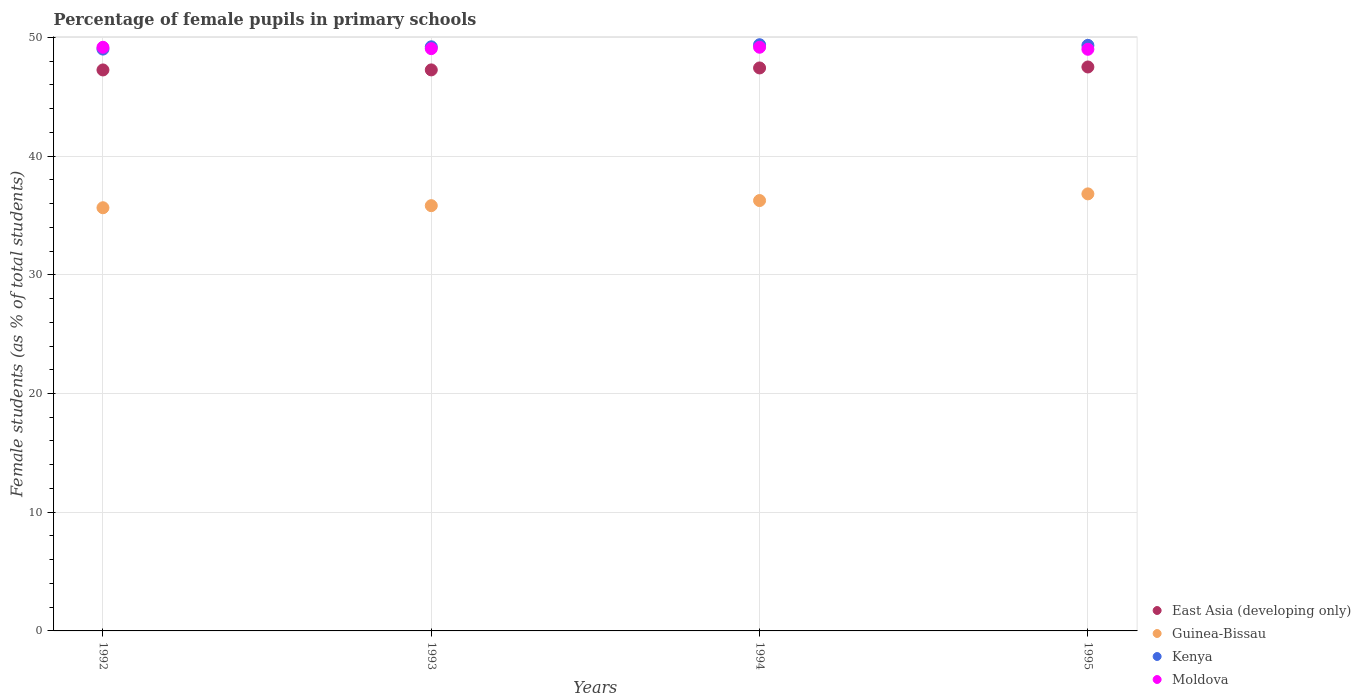What is the percentage of female pupils in primary schools in Kenya in 1994?
Your response must be concise. 49.38. Across all years, what is the maximum percentage of female pupils in primary schools in Kenya?
Give a very brief answer. 49.38. Across all years, what is the minimum percentage of female pupils in primary schools in Moldova?
Your answer should be compact. 49. In which year was the percentage of female pupils in primary schools in Kenya minimum?
Ensure brevity in your answer.  1992. What is the total percentage of female pupils in primary schools in Kenya in the graph?
Ensure brevity in your answer.  196.94. What is the difference between the percentage of female pupils in primary schools in Guinea-Bissau in 1992 and that in 1994?
Provide a succinct answer. -0.61. What is the difference between the percentage of female pupils in primary schools in East Asia (developing only) in 1992 and the percentage of female pupils in primary schools in Kenya in 1995?
Make the answer very short. -2.07. What is the average percentage of female pupils in primary schools in Moldova per year?
Provide a succinct answer. 49.1. In the year 1994, what is the difference between the percentage of female pupils in primary schools in Kenya and percentage of female pupils in primary schools in Moldova?
Give a very brief answer. 0.21. What is the ratio of the percentage of female pupils in primary schools in Kenya in 1992 to that in 1993?
Your answer should be very brief. 1. Is the difference between the percentage of female pupils in primary schools in Kenya in 1992 and 1995 greater than the difference between the percentage of female pupils in primary schools in Moldova in 1992 and 1995?
Your response must be concise. No. What is the difference between the highest and the second highest percentage of female pupils in primary schools in East Asia (developing only)?
Your answer should be compact. 0.08. What is the difference between the highest and the lowest percentage of female pupils in primary schools in East Asia (developing only)?
Your response must be concise. 0.25. Is the sum of the percentage of female pupils in primary schools in Guinea-Bissau in 1993 and 1995 greater than the maximum percentage of female pupils in primary schools in Kenya across all years?
Give a very brief answer. Yes. Does the percentage of female pupils in primary schools in Guinea-Bissau monotonically increase over the years?
Your response must be concise. Yes. Is the percentage of female pupils in primary schools in East Asia (developing only) strictly less than the percentage of female pupils in primary schools in Guinea-Bissau over the years?
Provide a succinct answer. No. How many years are there in the graph?
Give a very brief answer. 4. What is the difference between two consecutive major ticks on the Y-axis?
Make the answer very short. 10. Does the graph contain grids?
Keep it short and to the point. Yes. What is the title of the graph?
Your answer should be compact. Percentage of female pupils in primary schools. Does "Syrian Arab Republic" appear as one of the legend labels in the graph?
Keep it short and to the point. No. What is the label or title of the X-axis?
Your answer should be very brief. Years. What is the label or title of the Y-axis?
Give a very brief answer. Female students (as % of total students). What is the Female students (as % of total students) of East Asia (developing only) in 1992?
Your answer should be compact. 47.26. What is the Female students (as % of total students) in Guinea-Bissau in 1992?
Keep it short and to the point. 35.65. What is the Female students (as % of total students) of Kenya in 1992?
Provide a succinct answer. 49.02. What is the Female students (as % of total students) of Moldova in 1992?
Ensure brevity in your answer.  49.17. What is the Female students (as % of total students) of East Asia (developing only) in 1993?
Provide a short and direct response. 47.26. What is the Female students (as % of total students) of Guinea-Bissau in 1993?
Provide a short and direct response. 35.83. What is the Female students (as % of total students) in Kenya in 1993?
Provide a succinct answer. 49.21. What is the Female students (as % of total students) of Moldova in 1993?
Offer a very short reply. 49.05. What is the Female students (as % of total students) in East Asia (developing only) in 1994?
Your answer should be compact. 47.43. What is the Female students (as % of total students) in Guinea-Bissau in 1994?
Provide a short and direct response. 36.26. What is the Female students (as % of total students) of Kenya in 1994?
Your response must be concise. 49.38. What is the Female students (as % of total students) in Moldova in 1994?
Provide a succinct answer. 49.17. What is the Female students (as % of total students) of East Asia (developing only) in 1995?
Provide a short and direct response. 47.51. What is the Female students (as % of total students) in Guinea-Bissau in 1995?
Offer a very short reply. 36.82. What is the Female students (as % of total students) of Kenya in 1995?
Keep it short and to the point. 49.33. What is the Female students (as % of total students) in Moldova in 1995?
Give a very brief answer. 49. Across all years, what is the maximum Female students (as % of total students) in East Asia (developing only)?
Provide a short and direct response. 47.51. Across all years, what is the maximum Female students (as % of total students) in Guinea-Bissau?
Your answer should be very brief. 36.82. Across all years, what is the maximum Female students (as % of total students) of Kenya?
Your answer should be compact. 49.38. Across all years, what is the maximum Female students (as % of total students) in Moldova?
Provide a short and direct response. 49.17. Across all years, what is the minimum Female students (as % of total students) in East Asia (developing only)?
Your answer should be very brief. 47.26. Across all years, what is the minimum Female students (as % of total students) in Guinea-Bissau?
Offer a very short reply. 35.65. Across all years, what is the minimum Female students (as % of total students) of Kenya?
Your answer should be compact. 49.02. Across all years, what is the minimum Female students (as % of total students) of Moldova?
Offer a very short reply. 49. What is the total Female students (as % of total students) of East Asia (developing only) in the graph?
Give a very brief answer. 189.46. What is the total Female students (as % of total students) in Guinea-Bissau in the graph?
Your answer should be very brief. 144.55. What is the total Female students (as % of total students) of Kenya in the graph?
Ensure brevity in your answer.  196.94. What is the total Female students (as % of total students) in Moldova in the graph?
Give a very brief answer. 196.39. What is the difference between the Female students (as % of total students) in East Asia (developing only) in 1992 and that in 1993?
Provide a succinct answer. -0. What is the difference between the Female students (as % of total students) of Guinea-Bissau in 1992 and that in 1993?
Provide a short and direct response. -0.18. What is the difference between the Female students (as % of total students) of Kenya in 1992 and that in 1993?
Make the answer very short. -0.19. What is the difference between the Female students (as % of total students) of Moldova in 1992 and that in 1993?
Ensure brevity in your answer.  0.11. What is the difference between the Female students (as % of total students) of East Asia (developing only) in 1992 and that in 1994?
Offer a very short reply. -0.17. What is the difference between the Female students (as % of total students) of Guinea-Bissau in 1992 and that in 1994?
Make the answer very short. -0.61. What is the difference between the Female students (as % of total students) of Kenya in 1992 and that in 1994?
Your response must be concise. -0.37. What is the difference between the Female students (as % of total students) in Moldova in 1992 and that in 1994?
Offer a terse response. -0. What is the difference between the Female students (as % of total students) in East Asia (developing only) in 1992 and that in 1995?
Your answer should be compact. -0.25. What is the difference between the Female students (as % of total students) in Guinea-Bissau in 1992 and that in 1995?
Your response must be concise. -1.17. What is the difference between the Female students (as % of total students) of Kenya in 1992 and that in 1995?
Provide a short and direct response. -0.31. What is the difference between the Female students (as % of total students) of Moldova in 1992 and that in 1995?
Offer a terse response. 0.17. What is the difference between the Female students (as % of total students) in East Asia (developing only) in 1993 and that in 1994?
Your answer should be very brief. -0.16. What is the difference between the Female students (as % of total students) of Guinea-Bissau in 1993 and that in 1994?
Your answer should be compact. -0.43. What is the difference between the Female students (as % of total students) in Kenya in 1993 and that in 1994?
Make the answer very short. -0.17. What is the difference between the Female students (as % of total students) in Moldova in 1993 and that in 1994?
Offer a very short reply. -0.12. What is the difference between the Female students (as % of total students) of East Asia (developing only) in 1993 and that in 1995?
Ensure brevity in your answer.  -0.25. What is the difference between the Female students (as % of total students) in Guinea-Bissau in 1993 and that in 1995?
Your answer should be compact. -0.99. What is the difference between the Female students (as % of total students) of Kenya in 1993 and that in 1995?
Your answer should be very brief. -0.12. What is the difference between the Female students (as % of total students) of Moldova in 1993 and that in 1995?
Keep it short and to the point. 0.05. What is the difference between the Female students (as % of total students) of East Asia (developing only) in 1994 and that in 1995?
Ensure brevity in your answer.  -0.08. What is the difference between the Female students (as % of total students) in Guinea-Bissau in 1994 and that in 1995?
Offer a very short reply. -0.56. What is the difference between the Female students (as % of total students) of Kenya in 1994 and that in 1995?
Provide a succinct answer. 0.05. What is the difference between the Female students (as % of total students) of Moldova in 1994 and that in 1995?
Your answer should be compact. 0.17. What is the difference between the Female students (as % of total students) of East Asia (developing only) in 1992 and the Female students (as % of total students) of Guinea-Bissau in 1993?
Your answer should be compact. 11.43. What is the difference between the Female students (as % of total students) of East Asia (developing only) in 1992 and the Female students (as % of total students) of Kenya in 1993?
Provide a short and direct response. -1.95. What is the difference between the Female students (as % of total students) of East Asia (developing only) in 1992 and the Female students (as % of total students) of Moldova in 1993?
Your answer should be compact. -1.79. What is the difference between the Female students (as % of total students) of Guinea-Bissau in 1992 and the Female students (as % of total students) of Kenya in 1993?
Ensure brevity in your answer.  -13.56. What is the difference between the Female students (as % of total students) in Guinea-Bissau in 1992 and the Female students (as % of total students) in Moldova in 1993?
Make the answer very short. -13.4. What is the difference between the Female students (as % of total students) of Kenya in 1992 and the Female students (as % of total students) of Moldova in 1993?
Offer a very short reply. -0.04. What is the difference between the Female students (as % of total students) of East Asia (developing only) in 1992 and the Female students (as % of total students) of Guinea-Bissau in 1994?
Offer a terse response. 11. What is the difference between the Female students (as % of total students) in East Asia (developing only) in 1992 and the Female students (as % of total students) in Kenya in 1994?
Your answer should be very brief. -2.12. What is the difference between the Female students (as % of total students) of East Asia (developing only) in 1992 and the Female students (as % of total students) of Moldova in 1994?
Provide a succinct answer. -1.91. What is the difference between the Female students (as % of total students) in Guinea-Bissau in 1992 and the Female students (as % of total students) in Kenya in 1994?
Provide a short and direct response. -13.73. What is the difference between the Female students (as % of total students) of Guinea-Bissau in 1992 and the Female students (as % of total students) of Moldova in 1994?
Your response must be concise. -13.52. What is the difference between the Female students (as % of total students) of Kenya in 1992 and the Female students (as % of total students) of Moldova in 1994?
Provide a short and direct response. -0.16. What is the difference between the Female students (as % of total students) in East Asia (developing only) in 1992 and the Female students (as % of total students) in Guinea-Bissau in 1995?
Make the answer very short. 10.44. What is the difference between the Female students (as % of total students) in East Asia (developing only) in 1992 and the Female students (as % of total students) in Kenya in 1995?
Provide a short and direct response. -2.07. What is the difference between the Female students (as % of total students) of East Asia (developing only) in 1992 and the Female students (as % of total students) of Moldova in 1995?
Provide a succinct answer. -1.74. What is the difference between the Female students (as % of total students) of Guinea-Bissau in 1992 and the Female students (as % of total students) of Kenya in 1995?
Give a very brief answer. -13.68. What is the difference between the Female students (as % of total students) in Guinea-Bissau in 1992 and the Female students (as % of total students) in Moldova in 1995?
Your answer should be very brief. -13.35. What is the difference between the Female students (as % of total students) of Kenya in 1992 and the Female students (as % of total students) of Moldova in 1995?
Your answer should be very brief. 0.02. What is the difference between the Female students (as % of total students) of East Asia (developing only) in 1993 and the Female students (as % of total students) of Guinea-Bissau in 1994?
Your answer should be compact. 11.01. What is the difference between the Female students (as % of total students) of East Asia (developing only) in 1993 and the Female students (as % of total students) of Kenya in 1994?
Your answer should be very brief. -2.12. What is the difference between the Female students (as % of total students) in East Asia (developing only) in 1993 and the Female students (as % of total students) in Moldova in 1994?
Give a very brief answer. -1.91. What is the difference between the Female students (as % of total students) in Guinea-Bissau in 1993 and the Female students (as % of total students) in Kenya in 1994?
Your answer should be very brief. -13.56. What is the difference between the Female students (as % of total students) in Guinea-Bissau in 1993 and the Female students (as % of total students) in Moldova in 1994?
Offer a terse response. -13.35. What is the difference between the Female students (as % of total students) of Kenya in 1993 and the Female students (as % of total students) of Moldova in 1994?
Your response must be concise. 0.04. What is the difference between the Female students (as % of total students) of East Asia (developing only) in 1993 and the Female students (as % of total students) of Guinea-Bissau in 1995?
Offer a very short reply. 10.44. What is the difference between the Female students (as % of total students) in East Asia (developing only) in 1993 and the Female students (as % of total students) in Kenya in 1995?
Keep it short and to the point. -2.07. What is the difference between the Female students (as % of total students) of East Asia (developing only) in 1993 and the Female students (as % of total students) of Moldova in 1995?
Keep it short and to the point. -1.74. What is the difference between the Female students (as % of total students) in Guinea-Bissau in 1993 and the Female students (as % of total students) in Kenya in 1995?
Keep it short and to the point. -13.5. What is the difference between the Female students (as % of total students) of Guinea-Bissau in 1993 and the Female students (as % of total students) of Moldova in 1995?
Make the answer very short. -13.17. What is the difference between the Female students (as % of total students) in Kenya in 1993 and the Female students (as % of total students) in Moldova in 1995?
Ensure brevity in your answer.  0.21. What is the difference between the Female students (as % of total students) in East Asia (developing only) in 1994 and the Female students (as % of total students) in Guinea-Bissau in 1995?
Your response must be concise. 10.61. What is the difference between the Female students (as % of total students) of East Asia (developing only) in 1994 and the Female students (as % of total students) of Kenya in 1995?
Offer a very short reply. -1.9. What is the difference between the Female students (as % of total students) in East Asia (developing only) in 1994 and the Female students (as % of total students) in Moldova in 1995?
Your answer should be compact. -1.57. What is the difference between the Female students (as % of total students) in Guinea-Bissau in 1994 and the Female students (as % of total students) in Kenya in 1995?
Keep it short and to the point. -13.07. What is the difference between the Female students (as % of total students) of Guinea-Bissau in 1994 and the Female students (as % of total students) of Moldova in 1995?
Your response must be concise. -12.74. What is the difference between the Female students (as % of total students) in Kenya in 1994 and the Female students (as % of total students) in Moldova in 1995?
Your answer should be very brief. 0.38. What is the average Female students (as % of total students) in East Asia (developing only) per year?
Provide a succinct answer. 47.36. What is the average Female students (as % of total students) in Guinea-Bissau per year?
Ensure brevity in your answer.  36.14. What is the average Female students (as % of total students) in Kenya per year?
Provide a short and direct response. 49.23. What is the average Female students (as % of total students) in Moldova per year?
Your response must be concise. 49.1. In the year 1992, what is the difference between the Female students (as % of total students) in East Asia (developing only) and Female students (as % of total students) in Guinea-Bissau?
Offer a terse response. 11.61. In the year 1992, what is the difference between the Female students (as % of total students) of East Asia (developing only) and Female students (as % of total students) of Kenya?
Keep it short and to the point. -1.76. In the year 1992, what is the difference between the Female students (as % of total students) in East Asia (developing only) and Female students (as % of total students) in Moldova?
Provide a succinct answer. -1.91. In the year 1992, what is the difference between the Female students (as % of total students) of Guinea-Bissau and Female students (as % of total students) of Kenya?
Offer a very short reply. -13.37. In the year 1992, what is the difference between the Female students (as % of total students) in Guinea-Bissau and Female students (as % of total students) in Moldova?
Ensure brevity in your answer.  -13.52. In the year 1992, what is the difference between the Female students (as % of total students) of Kenya and Female students (as % of total students) of Moldova?
Your response must be concise. -0.15. In the year 1993, what is the difference between the Female students (as % of total students) of East Asia (developing only) and Female students (as % of total students) of Guinea-Bissau?
Provide a short and direct response. 11.44. In the year 1993, what is the difference between the Female students (as % of total students) in East Asia (developing only) and Female students (as % of total students) in Kenya?
Provide a short and direct response. -1.95. In the year 1993, what is the difference between the Female students (as % of total students) of East Asia (developing only) and Female students (as % of total students) of Moldova?
Provide a short and direct response. -1.79. In the year 1993, what is the difference between the Female students (as % of total students) in Guinea-Bissau and Female students (as % of total students) in Kenya?
Provide a short and direct response. -13.38. In the year 1993, what is the difference between the Female students (as % of total students) of Guinea-Bissau and Female students (as % of total students) of Moldova?
Provide a succinct answer. -13.23. In the year 1993, what is the difference between the Female students (as % of total students) of Kenya and Female students (as % of total students) of Moldova?
Your answer should be very brief. 0.16. In the year 1994, what is the difference between the Female students (as % of total students) of East Asia (developing only) and Female students (as % of total students) of Guinea-Bissau?
Provide a short and direct response. 11.17. In the year 1994, what is the difference between the Female students (as % of total students) of East Asia (developing only) and Female students (as % of total students) of Kenya?
Your answer should be very brief. -1.96. In the year 1994, what is the difference between the Female students (as % of total students) of East Asia (developing only) and Female students (as % of total students) of Moldova?
Keep it short and to the point. -1.74. In the year 1994, what is the difference between the Female students (as % of total students) in Guinea-Bissau and Female students (as % of total students) in Kenya?
Offer a very short reply. -13.13. In the year 1994, what is the difference between the Female students (as % of total students) of Guinea-Bissau and Female students (as % of total students) of Moldova?
Your answer should be compact. -12.92. In the year 1994, what is the difference between the Female students (as % of total students) of Kenya and Female students (as % of total students) of Moldova?
Your answer should be compact. 0.21. In the year 1995, what is the difference between the Female students (as % of total students) in East Asia (developing only) and Female students (as % of total students) in Guinea-Bissau?
Offer a very short reply. 10.69. In the year 1995, what is the difference between the Female students (as % of total students) of East Asia (developing only) and Female students (as % of total students) of Kenya?
Give a very brief answer. -1.82. In the year 1995, what is the difference between the Female students (as % of total students) in East Asia (developing only) and Female students (as % of total students) in Moldova?
Make the answer very short. -1.49. In the year 1995, what is the difference between the Female students (as % of total students) in Guinea-Bissau and Female students (as % of total students) in Kenya?
Your response must be concise. -12.51. In the year 1995, what is the difference between the Female students (as % of total students) of Guinea-Bissau and Female students (as % of total students) of Moldova?
Offer a terse response. -12.18. In the year 1995, what is the difference between the Female students (as % of total students) of Kenya and Female students (as % of total students) of Moldova?
Keep it short and to the point. 0.33. What is the ratio of the Female students (as % of total students) in East Asia (developing only) in 1992 to that in 1993?
Offer a terse response. 1. What is the ratio of the Female students (as % of total students) of Guinea-Bissau in 1992 to that in 1994?
Provide a succinct answer. 0.98. What is the ratio of the Female students (as % of total students) in Moldova in 1992 to that in 1994?
Your answer should be very brief. 1. What is the ratio of the Female students (as % of total students) in Guinea-Bissau in 1992 to that in 1995?
Ensure brevity in your answer.  0.97. What is the ratio of the Female students (as % of total students) in Moldova in 1992 to that in 1995?
Make the answer very short. 1. What is the ratio of the Female students (as % of total students) of East Asia (developing only) in 1993 to that in 1994?
Give a very brief answer. 1. What is the ratio of the Female students (as % of total students) of Guinea-Bissau in 1993 to that in 1994?
Keep it short and to the point. 0.99. What is the ratio of the Female students (as % of total students) in Moldova in 1993 to that in 1994?
Give a very brief answer. 1. What is the ratio of the Female students (as % of total students) of Guinea-Bissau in 1993 to that in 1995?
Offer a terse response. 0.97. What is the ratio of the Female students (as % of total students) of Moldova in 1993 to that in 1995?
Your response must be concise. 1. What is the ratio of the Female students (as % of total students) of Guinea-Bissau in 1994 to that in 1995?
Make the answer very short. 0.98. What is the ratio of the Female students (as % of total students) of Kenya in 1994 to that in 1995?
Make the answer very short. 1. What is the ratio of the Female students (as % of total students) in Moldova in 1994 to that in 1995?
Offer a terse response. 1. What is the difference between the highest and the second highest Female students (as % of total students) in East Asia (developing only)?
Your answer should be very brief. 0.08. What is the difference between the highest and the second highest Female students (as % of total students) in Guinea-Bissau?
Make the answer very short. 0.56. What is the difference between the highest and the second highest Female students (as % of total students) in Kenya?
Provide a succinct answer. 0.05. What is the difference between the highest and the second highest Female students (as % of total students) of Moldova?
Your answer should be very brief. 0. What is the difference between the highest and the lowest Female students (as % of total students) in East Asia (developing only)?
Give a very brief answer. 0.25. What is the difference between the highest and the lowest Female students (as % of total students) in Guinea-Bissau?
Give a very brief answer. 1.17. What is the difference between the highest and the lowest Female students (as % of total students) in Kenya?
Your response must be concise. 0.37. What is the difference between the highest and the lowest Female students (as % of total students) of Moldova?
Keep it short and to the point. 0.17. 